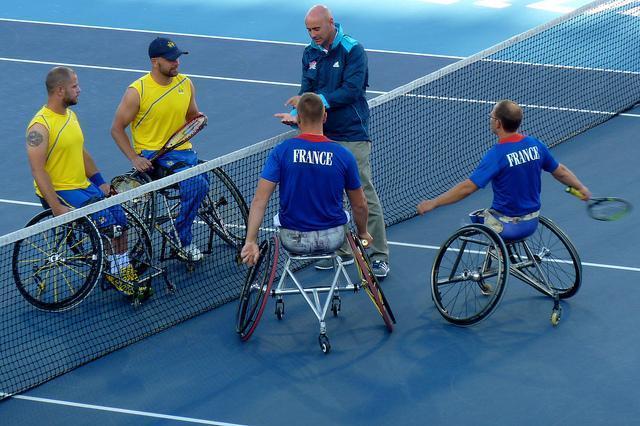How many people are in the photo?
Give a very brief answer. 5. 